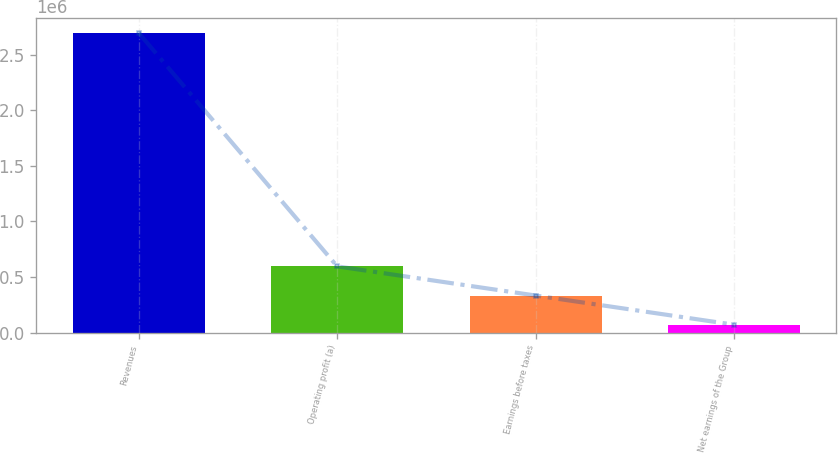Convert chart to OTSL. <chart><loc_0><loc_0><loc_500><loc_500><bar_chart><fcel>Revenues<fcel>Operating profit (a)<fcel>Earnings before taxes<fcel>Net earnings of the Group<nl><fcel>2.69387e+06<fcel>595524<fcel>333231<fcel>70937<nl></chart> 